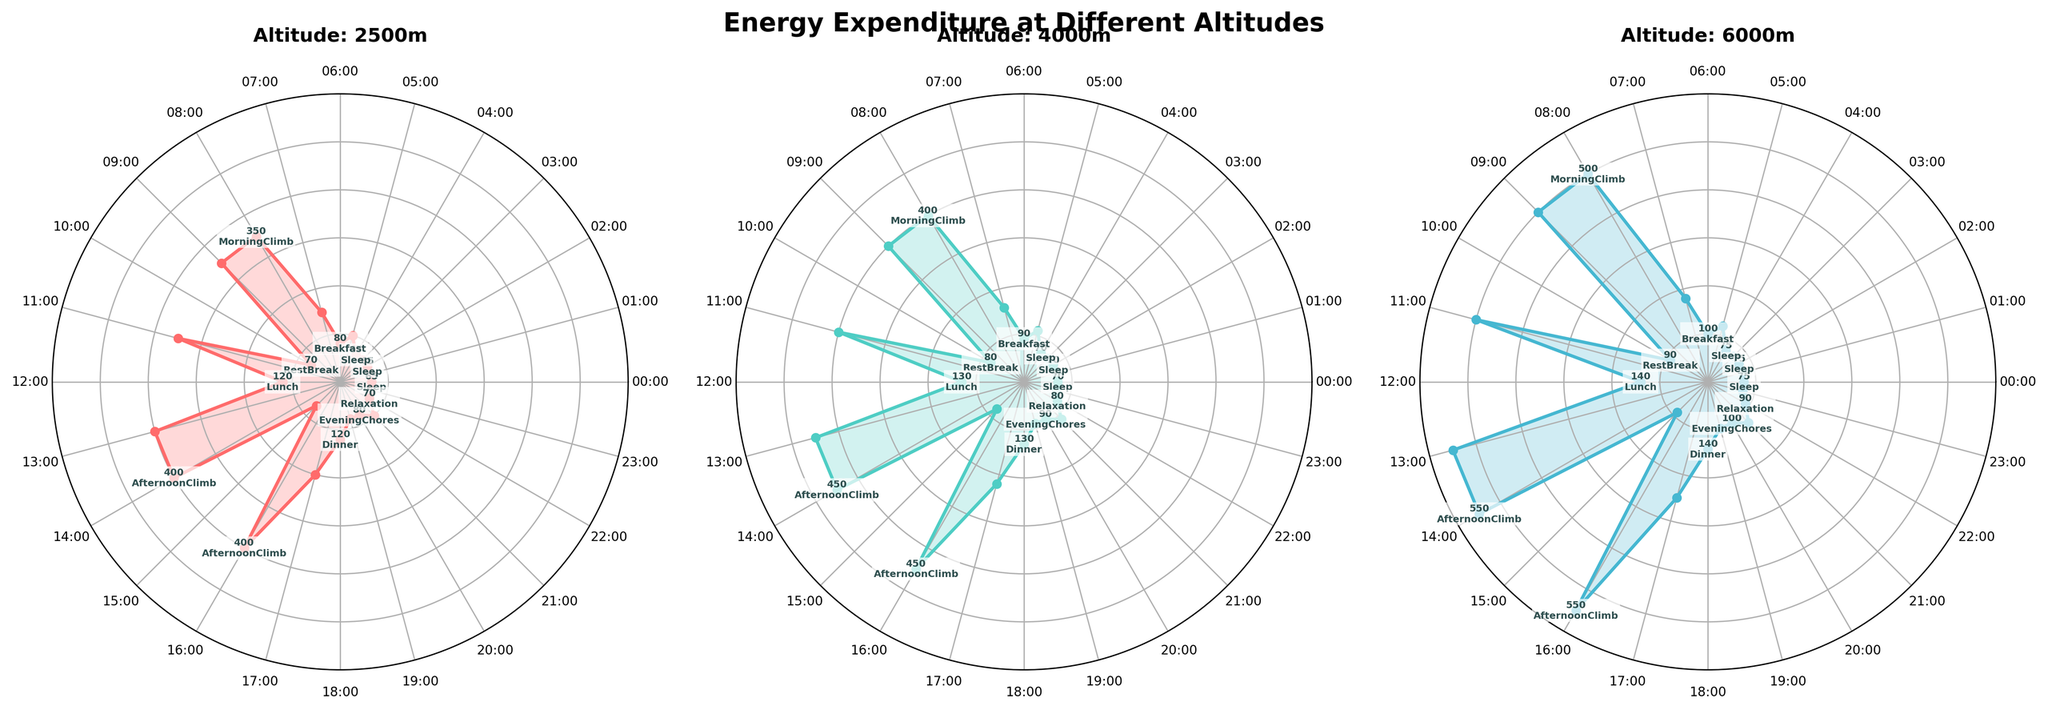What are the titles of the three subplots? The titles of the subplots are displayed at the top of each polar chart and indicate the altitude levels. The titles are "Altitude: 2500m", "Altitude: 4000m", and "Altitude: 6000m".
Answer: Altitude: 2500m, Altitude: 4000m, Altitude: 6000m Which hour has the highest energy expenditure at 6000m? Observing the radial distance of the various points on the 6000m subplot, the highest data point is labeled with the activity "AfternoonClimb" during the hours 13:00-14:00, 14:00-15:00, and 16:00-17:00 with a value of 550 kcal.
Answer: 13:00-14:00, 14:00-15:00, 16:00-17:00 Which activity takes place between 05:00 and 06:00, and what is the energy expenditure at 4000m during this time? From the polar plot, examine the labels between 05:00 and 06:00. The activity is "WakeUpPrep," with an energy expenditure of 110 kcal at 4000m.
Answer: WakeUpPrep, 110 kcal How does the energy expenditure for "MorningClimb" at 08:00-09:00 compare between 2500m and 6000m? Locate the values for "MorningClimb" at 08:00-09:00 on both the 2500m and 6000m charts. The values are 350 kcal at 2500m and 500 kcal at 6000m. The energy expenditure at 6000m is 150 kcal higher.
Answer: 150 kcal higher During which hours do all altitudes show the least energy expenditure, and what is the value? Examine each subplot for the minimum energy expenditure. The minimum energy expenditure appears during "Sleep" hours, specifically 00:00-01:00 and 23:00-00:00, with values of 65, 70, and 75 kcal for 2500m, 4000m, and 6000m respectively.
Answer: 00:00-01:00, 23:00-00:00; 65, 70, 75 kcal What is the total energy expenditure for "AfternoonClimb" across all altitudes from 14:00-15:00? Sum the energy expenditure for "AfternoonClimb" during 14:00-15:00 for each altitude: 400 kcal (2500m) + 450 kcal (4000m) + 550 kcal (6000m). The total is 1400 kcal.
Answer: 1400 kcal Which activity has a uniform energy expenditure across all three altitudes during 22:00-23:00? Inspect each subplot for the activity during 22:00-23:00. The activity is "Relaxation," with values of 70 kcal (2500m), 80 kcal (4000m), and 90 kcal (6000m), showing a uniform difference of 10 kcal between each altitude.
Answer: Relaxation Comparing "Lunch" and "Dinner," which has higher energy expenditure at 4000m and by how much? Check the energy expenditure for "Lunch" and "Dinner" on the 4000m subplot. "Lunch" has 130 kcal, while "Dinner" has 130 kcal. The values are the same, so the difference is 0 kcal.
Answer: No difference; 0 kcal 